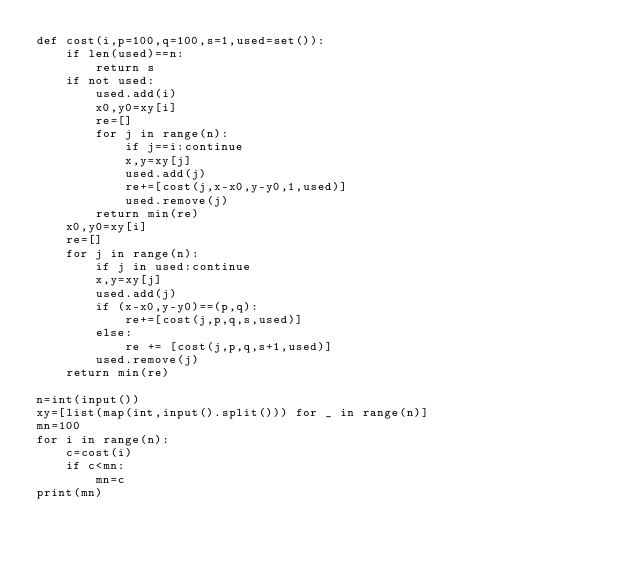Convert code to text. <code><loc_0><loc_0><loc_500><loc_500><_Python_>def cost(i,p=100,q=100,s=1,used=set()):
    if len(used)==n:
        return s
    if not used:
        used.add(i)
        x0,y0=xy[i]
        re=[]
        for j in range(n):
            if j==i:continue
            x,y=xy[j]
            used.add(j)
            re+=[cost(j,x-x0,y-y0,1,used)]
            used.remove(j)
        return min(re)
    x0,y0=xy[i]
    re=[]
    for j in range(n):
        if j in used:continue
        x,y=xy[j]
        used.add(j)
        if (x-x0,y-y0)==(p,q):
            re+=[cost(j,p,q,s,used)]
        else:
            re += [cost(j,p,q,s+1,used)]
        used.remove(j)
    return min(re)

n=int(input())
xy=[list(map(int,input().split())) for _ in range(n)]
mn=100
for i in range(n):
    c=cost(i)
    if c<mn:
        mn=c
print(mn)</code> 